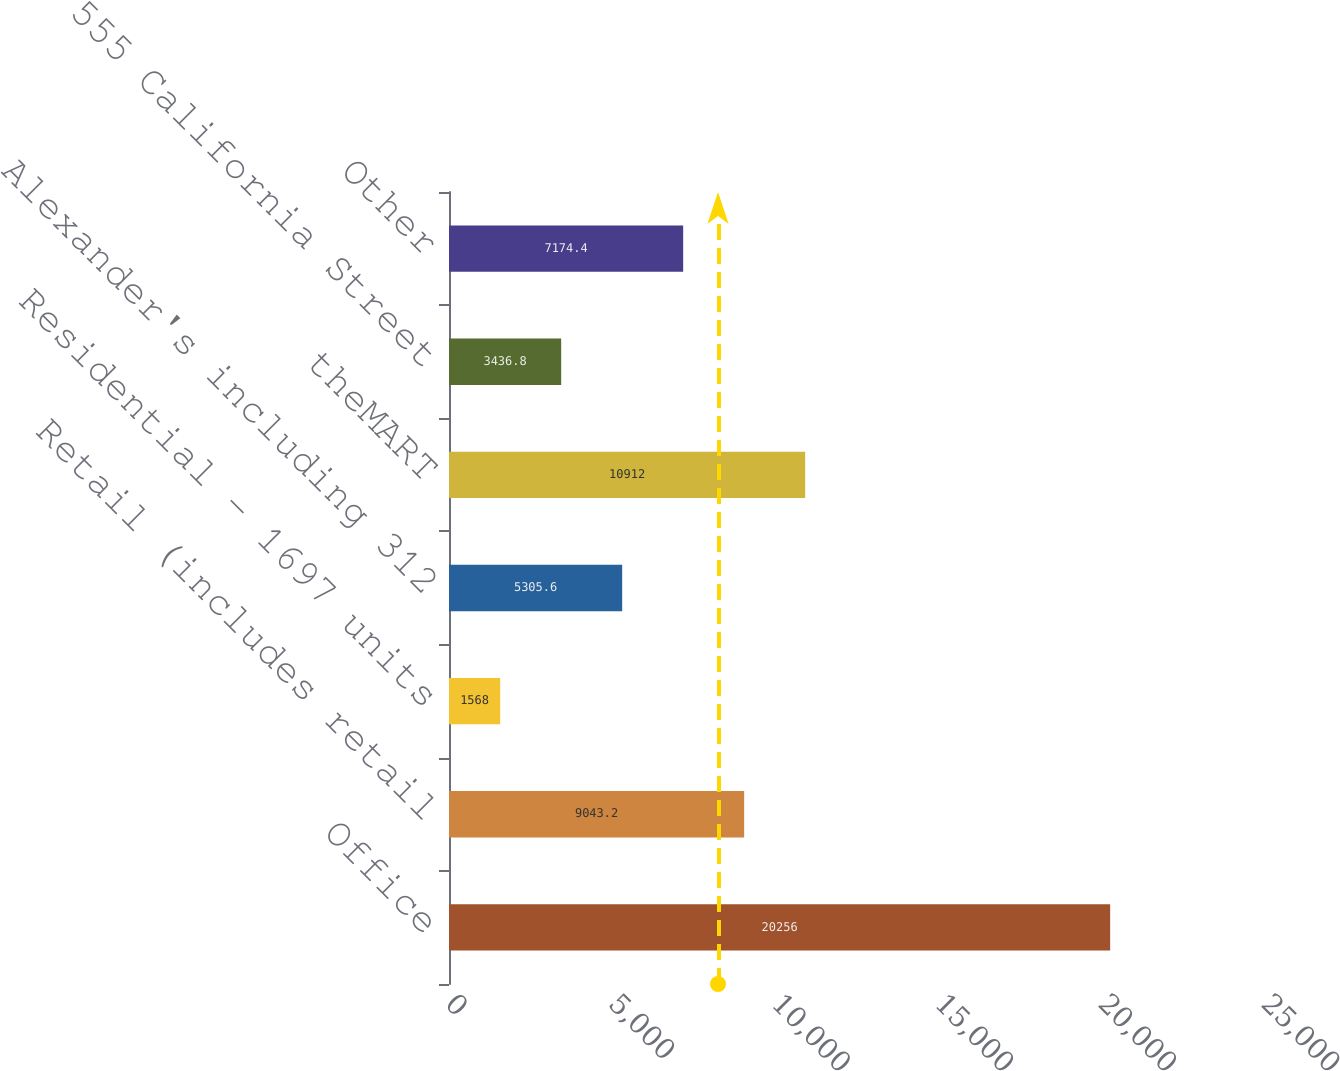Convert chart. <chart><loc_0><loc_0><loc_500><loc_500><bar_chart><fcel>Office<fcel>Retail (includes retail<fcel>Residential - 1697 units<fcel>Alexander's including 312<fcel>theMART<fcel>555 California Street<fcel>Other<nl><fcel>20256<fcel>9043.2<fcel>1568<fcel>5305.6<fcel>10912<fcel>3436.8<fcel>7174.4<nl></chart> 